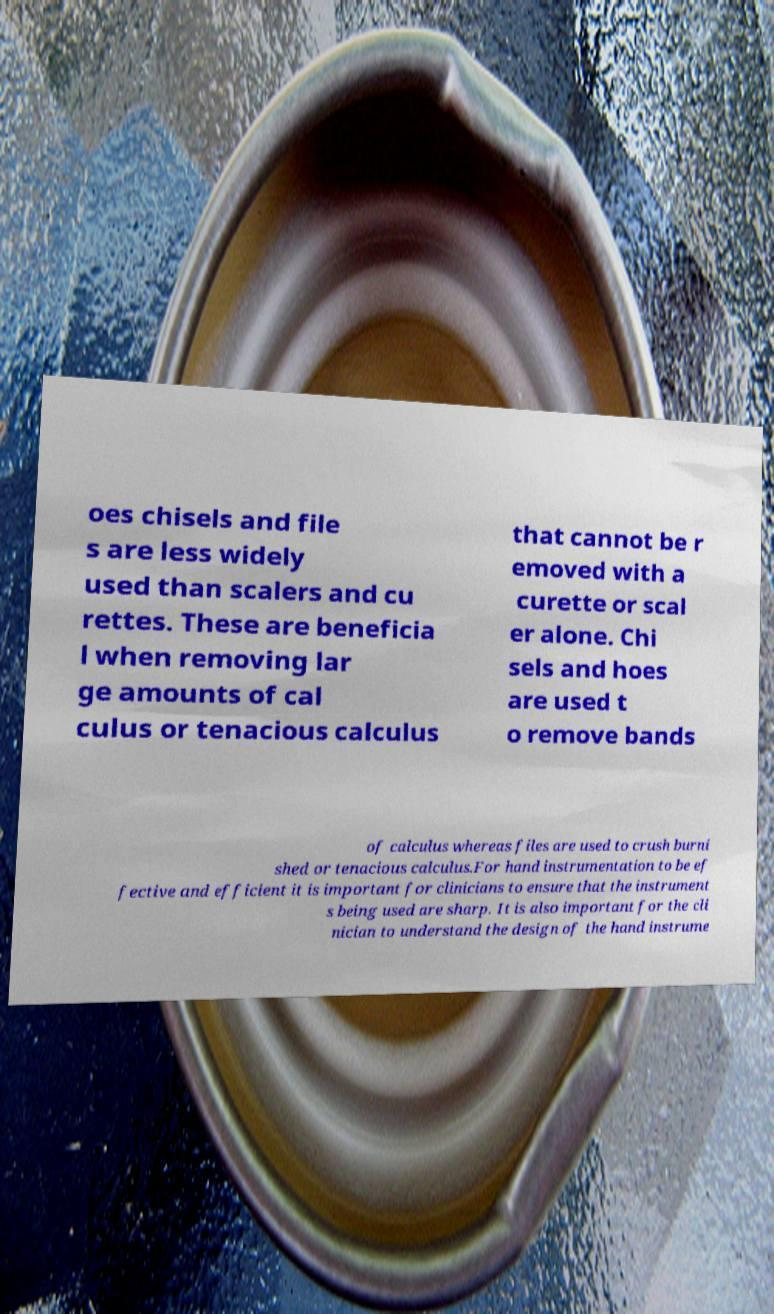Can you read and provide the text displayed in the image?This photo seems to have some interesting text. Can you extract and type it out for me? oes chisels and file s are less widely used than scalers and cu rettes. These are beneficia l when removing lar ge amounts of cal culus or tenacious calculus that cannot be r emoved with a curette or scal er alone. Chi sels and hoes are used t o remove bands of calculus whereas files are used to crush burni shed or tenacious calculus.For hand instrumentation to be ef fective and efficient it is important for clinicians to ensure that the instrument s being used are sharp. It is also important for the cli nician to understand the design of the hand instrume 